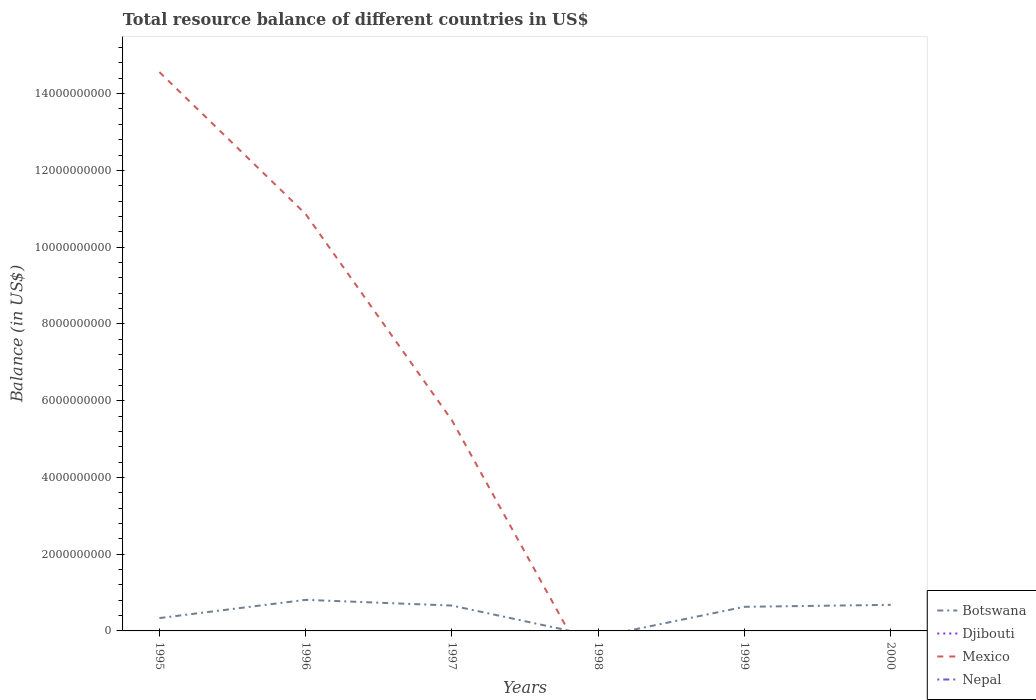Across all years, what is the maximum total resource balance in Mexico?
Provide a succinct answer. 0. What is the total total resource balance in Botswana in the graph?
Keep it short and to the point. -4.75e+08. What is the difference between the highest and the second highest total resource balance in Botswana?
Offer a terse response. 8.10e+08. Is the total resource balance in Botswana strictly greater than the total resource balance in Mexico over the years?
Your answer should be compact. No. Are the values on the major ticks of Y-axis written in scientific E-notation?
Offer a terse response. No. Does the graph contain any zero values?
Your answer should be very brief. Yes. Does the graph contain grids?
Offer a terse response. No. How are the legend labels stacked?
Your response must be concise. Vertical. What is the title of the graph?
Provide a short and direct response. Total resource balance of different countries in US$. What is the label or title of the X-axis?
Provide a succinct answer. Years. What is the label or title of the Y-axis?
Your answer should be compact. Balance (in US$). What is the Balance (in US$) in Botswana in 1995?
Provide a succinct answer. 3.35e+08. What is the Balance (in US$) in Mexico in 1995?
Ensure brevity in your answer.  1.46e+1. What is the Balance (in US$) of Botswana in 1996?
Provide a succinct answer. 8.10e+08. What is the Balance (in US$) of Mexico in 1996?
Make the answer very short. 1.09e+1. What is the Balance (in US$) in Nepal in 1996?
Ensure brevity in your answer.  0. What is the Balance (in US$) of Botswana in 1997?
Make the answer very short. 6.61e+08. What is the Balance (in US$) of Mexico in 1997?
Offer a very short reply. 5.49e+09. What is the Balance (in US$) of Nepal in 1997?
Your response must be concise. 0. What is the Balance (in US$) in Botswana in 1999?
Provide a succinct answer. 6.29e+08. What is the Balance (in US$) of Nepal in 1999?
Provide a short and direct response. 0. What is the Balance (in US$) of Botswana in 2000?
Offer a very short reply. 6.79e+08. What is the Balance (in US$) of Djibouti in 2000?
Provide a succinct answer. 0. What is the Balance (in US$) in Mexico in 2000?
Keep it short and to the point. 0. What is the Balance (in US$) of Nepal in 2000?
Keep it short and to the point. 0. Across all years, what is the maximum Balance (in US$) of Botswana?
Provide a succinct answer. 8.10e+08. Across all years, what is the maximum Balance (in US$) of Mexico?
Offer a terse response. 1.46e+1. Across all years, what is the minimum Balance (in US$) of Botswana?
Make the answer very short. 0. Across all years, what is the minimum Balance (in US$) of Mexico?
Your answer should be very brief. 0. What is the total Balance (in US$) of Botswana in the graph?
Keep it short and to the point. 3.11e+09. What is the total Balance (in US$) in Mexico in the graph?
Ensure brevity in your answer.  3.09e+1. What is the total Balance (in US$) in Nepal in the graph?
Offer a very short reply. 0. What is the difference between the Balance (in US$) in Botswana in 1995 and that in 1996?
Provide a succinct answer. -4.75e+08. What is the difference between the Balance (in US$) of Mexico in 1995 and that in 1996?
Provide a succinct answer. 3.70e+09. What is the difference between the Balance (in US$) of Botswana in 1995 and that in 1997?
Provide a succinct answer. -3.26e+08. What is the difference between the Balance (in US$) in Mexico in 1995 and that in 1997?
Make the answer very short. 9.07e+09. What is the difference between the Balance (in US$) of Botswana in 1995 and that in 1999?
Your answer should be compact. -2.94e+08. What is the difference between the Balance (in US$) in Botswana in 1995 and that in 2000?
Your response must be concise. -3.45e+08. What is the difference between the Balance (in US$) in Botswana in 1996 and that in 1997?
Make the answer very short. 1.49e+08. What is the difference between the Balance (in US$) in Mexico in 1996 and that in 1997?
Your response must be concise. 5.37e+09. What is the difference between the Balance (in US$) of Botswana in 1996 and that in 1999?
Provide a succinct answer. 1.81e+08. What is the difference between the Balance (in US$) of Botswana in 1996 and that in 2000?
Give a very brief answer. 1.30e+08. What is the difference between the Balance (in US$) in Botswana in 1997 and that in 1999?
Provide a succinct answer. 3.17e+07. What is the difference between the Balance (in US$) of Botswana in 1997 and that in 2000?
Your answer should be very brief. -1.90e+07. What is the difference between the Balance (in US$) of Botswana in 1999 and that in 2000?
Provide a succinct answer. -5.07e+07. What is the difference between the Balance (in US$) in Botswana in 1995 and the Balance (in US$) in Mexico in 1996?
Provide a short and direct response. -1.05e+1. What is the difference between the Balance (in US$) in Botswana in 1995 and the Balance (in US$) in Mexico in 1997?
Your response must be concise. -5.15e+09. What is the difference between the Balance (in US$) of Botswana in 1996 and the Balance (in US$) of Mexico in 1997?
Provide a short and direct response. -4.68e+09. What is the average Balance (in US$) of Botswana per year?
Give a very brief answer. 5.19e+08. What is the average Balance (in US$) in Mexico per year?
Keep it short and to the point. 5.15e+09. What is the average Balance (in US$) of Nepal per year?
Your answer should be very brief. 0. In the year 1995, what is the difference between the Balance (in US$) of Botswana and Balance (in US$) of Mexico?
Ensure brevity in your answer.  -1.42e+1. In the year 1996, what is the difference between the Balance (in US$) in Botswana and Balance (in US$) in Mexico?
Your response must be concise. -1.01e+1. In the year 1997, what is the difference between the Balance (in US$) in Botswana and Balance (in US$) in Mexico?
Your answer should be compact. -4.83e+09. What is the ratio of the Balance (in US$) in Botswana in 1995 to that in 1996?
Give a very brief answer. 0.41. What is the ratio of the Balance (in US$) of Mexico in 1995 to that in 1996?
Offer a terse response. 1.34. What is the ratio of the Balance (in US$) of Botswana in 1995 to that in 1997?
Give a very brief answer. 0.51. What is the ratio of the Balance (in US$) of Mexico in 1995 to that in 1997?
Provide a short and direct response. 2.65. What is the ratio of the Balance (in US$) of Botswana in 1995 to that in 1999?
Your answer should be compact. 0.53. What is the ratio of the Balance (in US$) of Botswana in 1995 to that in 2000?
Make the answer very short. 0.49. What is the ratio of the Balance (in US$) of Botswana in 1996 to that in 1997?
Keep it short and to the point. 1.23. What is the ratio of the Balance (in US$) of Mexico in 1996 to that in 1997?
Your response must be concise. 1.98. What is the ratio of the Balance (in US$) of Botswana in 1996 to that in 1999?
Provide a succinct answer. 1.29. What is the ratio of the Balance (in US$) of Botswana in 1996 to that in 2000?
Your answer should be compact. 1.19. What is the ratio of the Balance (in US$) of Botswana in 1997 to that in 1999?
Give a very brief answer. 1.05. What is the ratio of the Balance (in US$) in Botswana in 1997 to that in 2000?
Make the answer very short. 0.97. What is the ratio of the Balance (in US$) in Botswana in 1999 to that in 2000?
Give a very brief answer. 0.93. What is the difference between the highest and the second highest Balance (in US$) in Botswana?
Offer a terse response. 1.30e+08. What is the difference between the highest and the second highest Balance (in US$) in Mexico?
Offer a terse response. 3.70e+09. What is the difference between the highest and the lowest Balance (in US$) in Botswana?
Keep it short and to the point. 8.10e+08. What is the difference between the highest and the lowest Balance (in US$) of Mexico?
Give a very brief answer. 1.46e+1. 